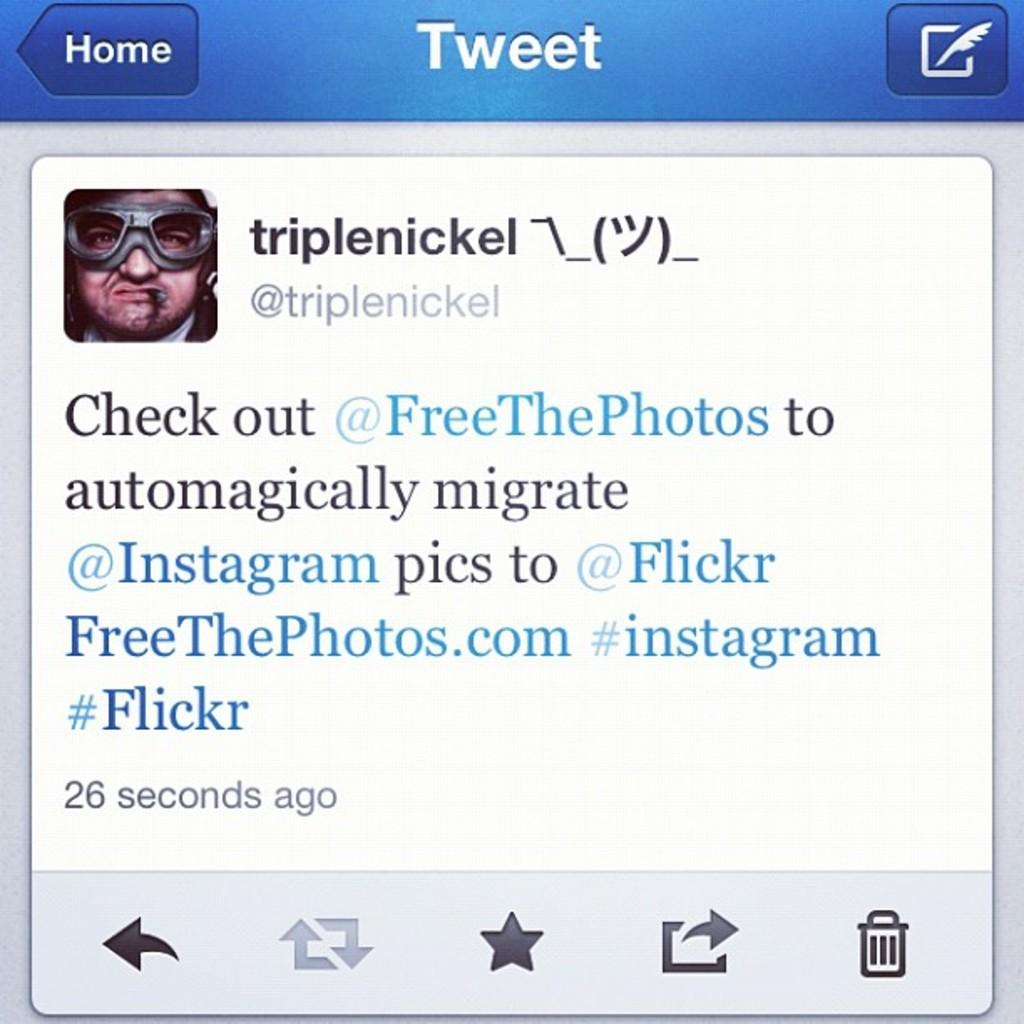What type of content is shown in the image? The image is a snapshot of a website. What can be found on the website? There is text on the website. Are there any visual elements on the website? Yes, there is an image of a person on the website. What type of pickle is being sold on the website? There is no mention of pickles or any type of pickle being sold on the website, as the image only shows text and an image of a person. 